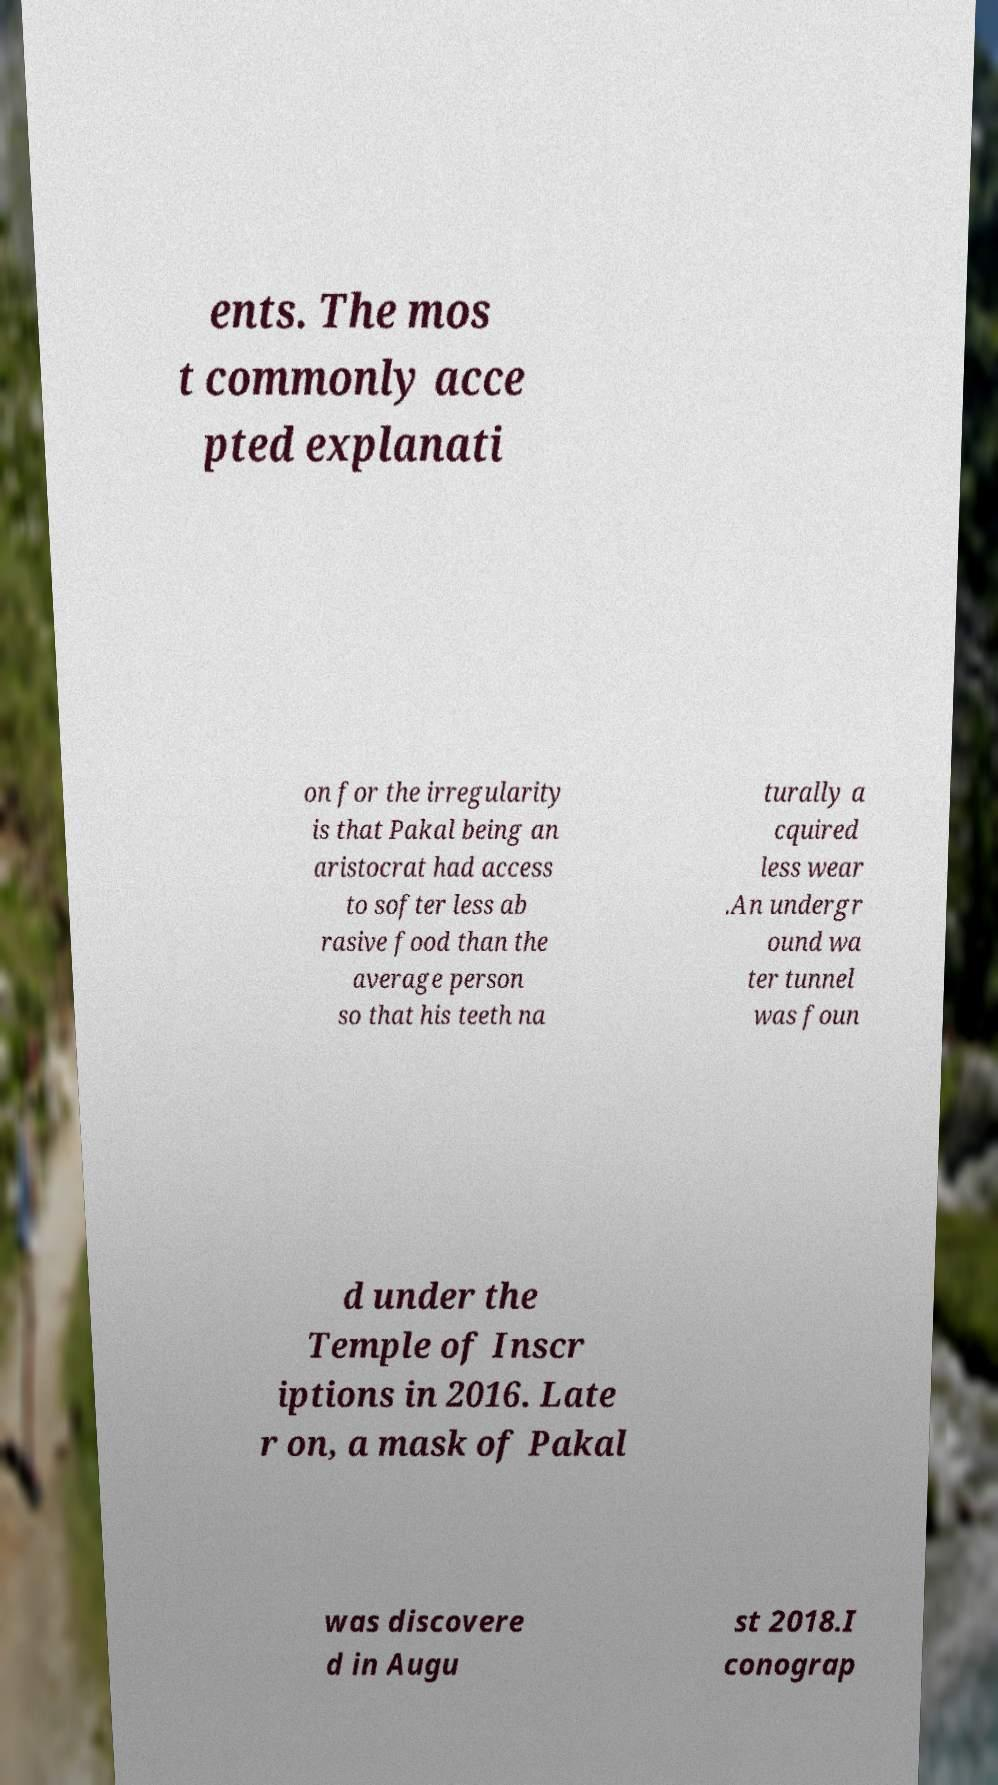Could you extract and type out the text from this image? ents. The mos t commonly acce pted explanati on for the irregularity is that Pakal being an aristocrat had access to softer less ab rasive food than the average person so that his teeth na turally a cquired less wear .An undergr ound wa ter tunnel was foun d under the Temple of Inscr iptions in 2016. Late r on, a mask of Pakal was discovere d in Augu st 2018.I conograp 